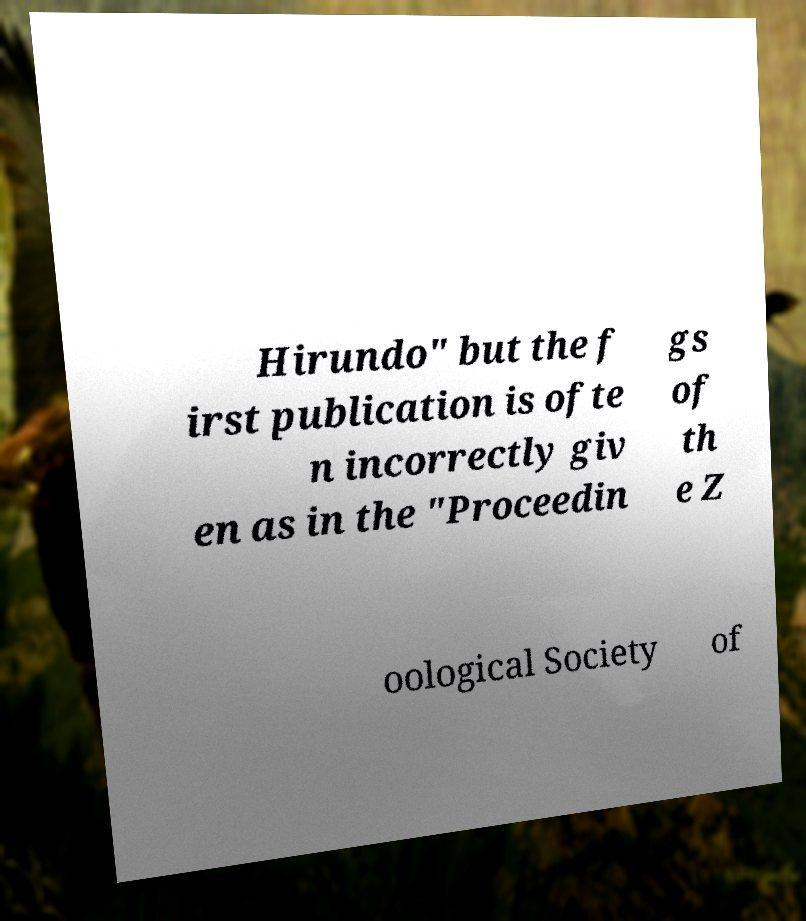Can you read and provide the text displayed in the image?This photo seems to have some interesting text. Can you extract and type it out for me? Hirundo" but the f irst publication is ofte n incorrectly giv en as in the "Proceedin gs of th e Z oological Society of 